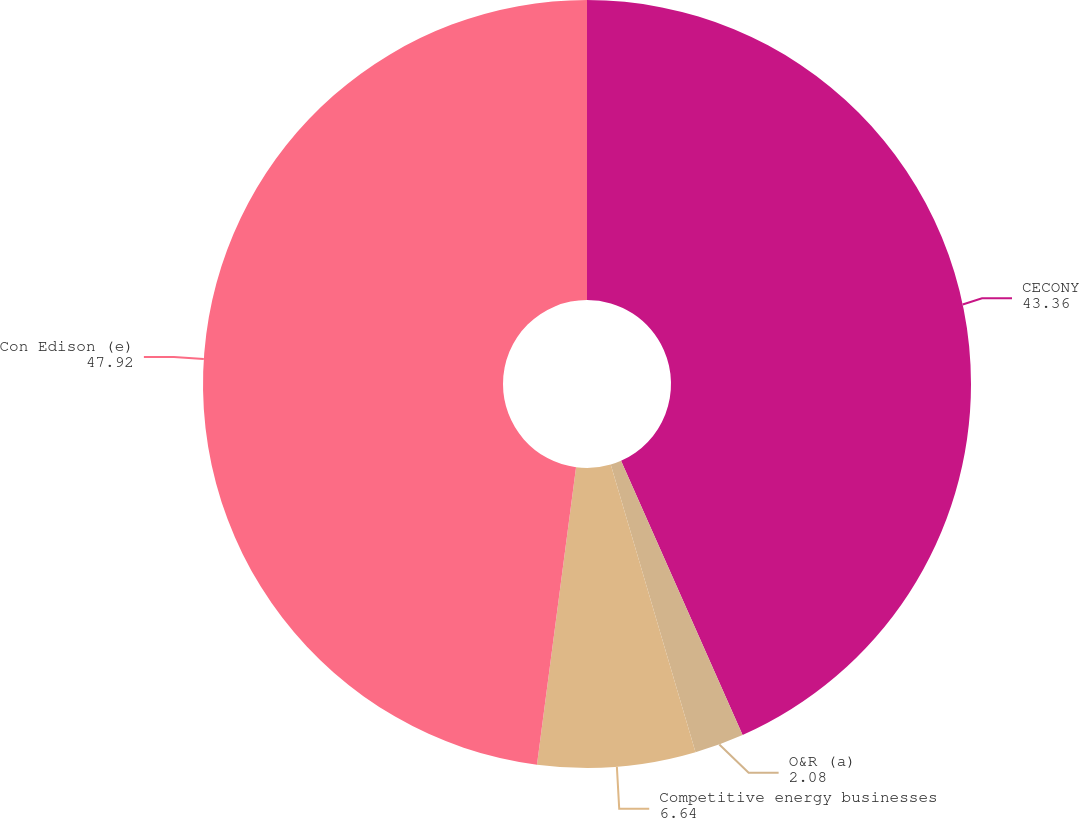<chart> <loc_0><loc_0><loc_500><loc_500><pie_chart><fcel>CECONY<fcel>O&R (a)<fcel>Competitive energy businesses<fcel>Con Edison (e)<nl><fcel>43.36%<fcel>2.08%<fcel>6.64%<fcel>47.92%<nl></chart> 